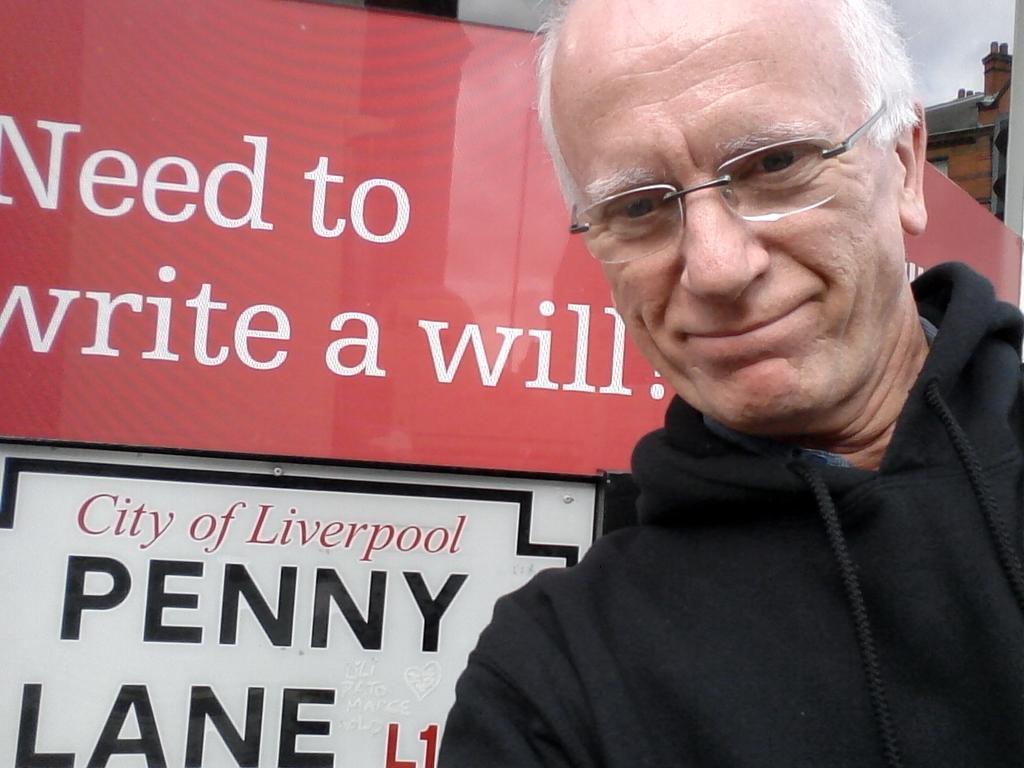How would you summarize this image in a sentence or two? In the image there is an old man with white hair in black hoodie standing on the right side in front of a banner. 